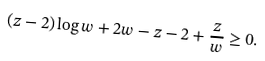<formula> <loc_0><loc_0><loc_500><loc_500>( z - 2 ) \log w + 2 w - z - 2 + \frac { z } { w } \geq 0 .</formula> 